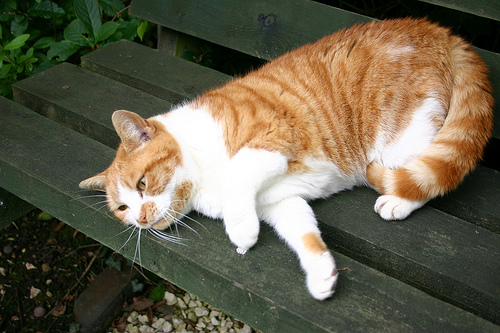<image>
Is the cat behind the table? No. The cat is not behind the table. From this viewpoint, the cat appears to be positioned elsewhere in the scene. 